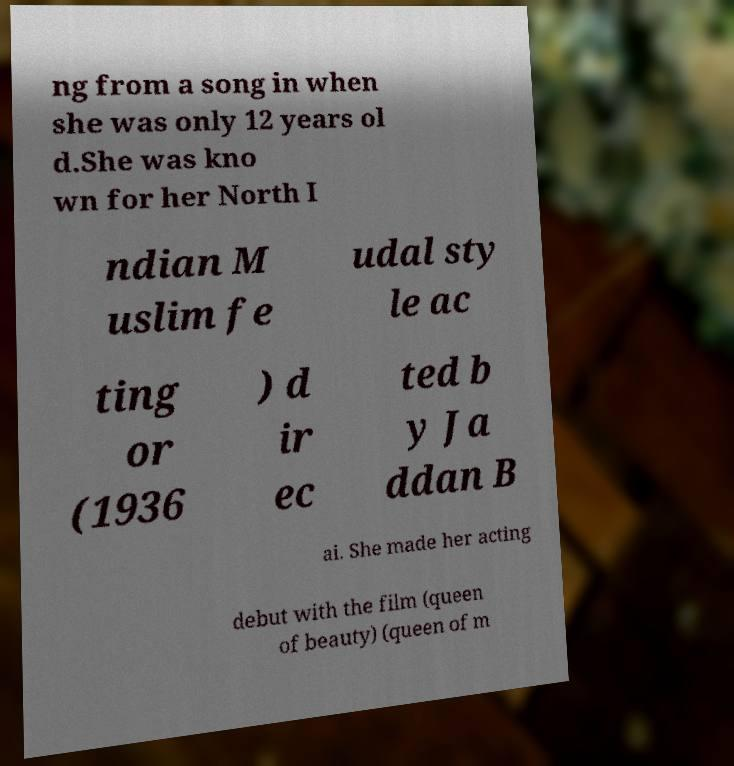There's text embedded in this image that I need extracted. Can you transcribe it verbatim? ng from a song in when she was only 12 years ol d.She was kno wn for her North I ndian M uslim fe udal sty le ac ting or (1936 ) d ir ec ted b y Ja ddan B ai. She made her acting debut with the film (queen of beauty) (queen of m 